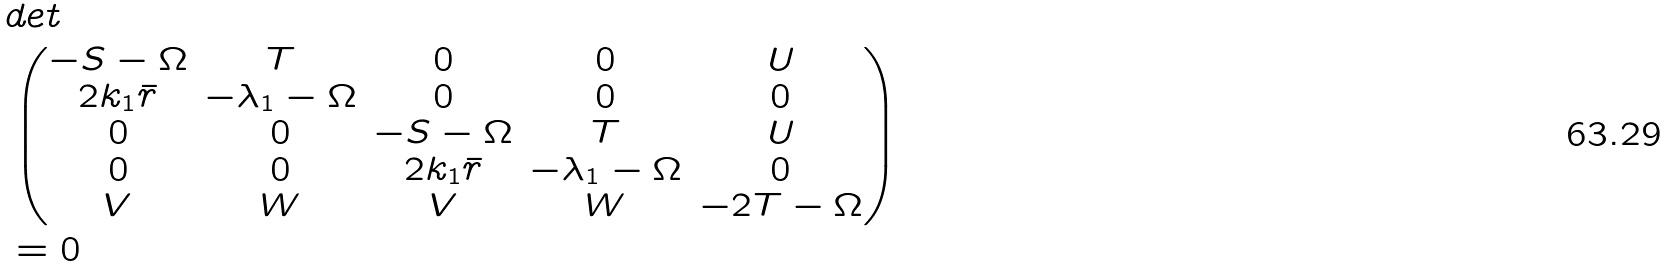<formula> <loc_0><loc_0><loc_500><loc_500>& d e t \\ & \begin{pmatrix} - S - \Omega & T & 0 & 0 & U \\ 2 k _ { 1 } \bar { r } & - \lambda _ { 1 } - \Omega & 0 & 0 & 0 \\ 0 & 0 & - S - \Omega & T & U \\ 0 & 0 & 2 k _ { 1 } \bar { r } & - \lambda _ { 1 } - \Omega & 0 \\ V & W & V & W & - 2 T - \Omega \end{pmatrix} \\ & = 0</formula> 